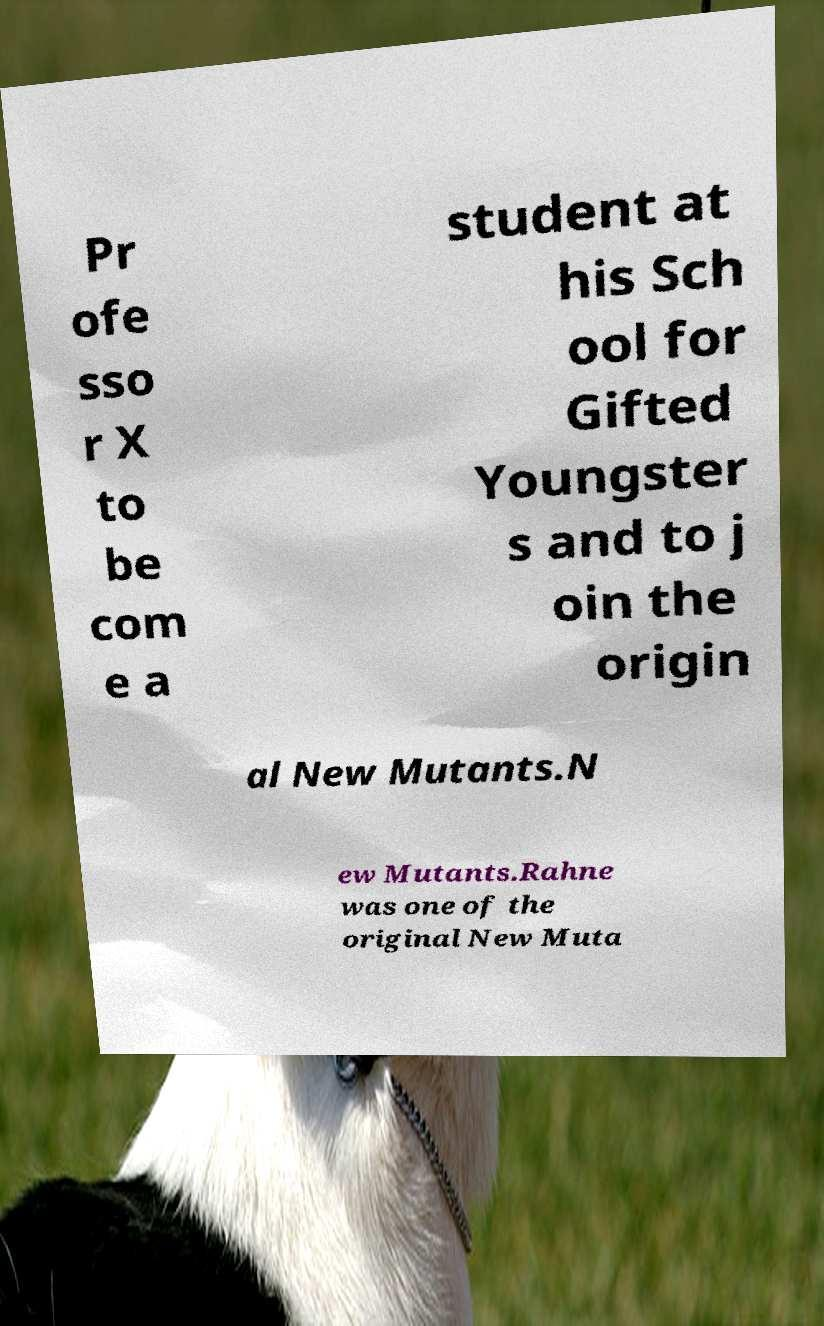For documentation purposes, I need the text within this image transcribed. Could you provide that? Pr ofe sso r X to be com e a student at his Sch ool for Gifted Youngster s and to j oin the origin al New Mutants.N ew Mutants.Rahne was one of the original New Muta 